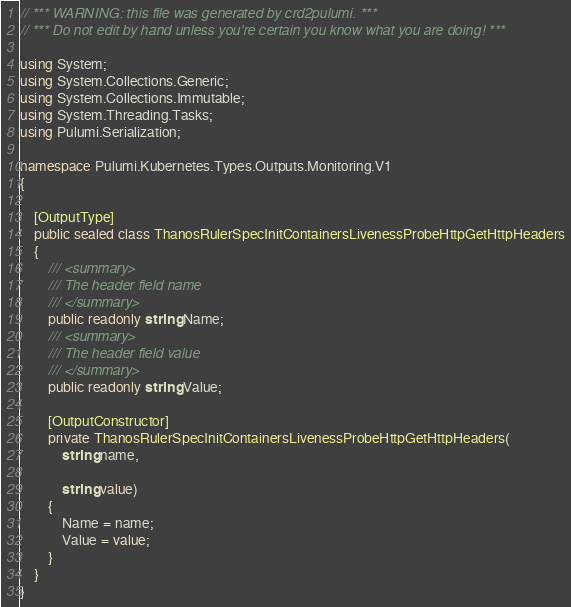Convert code to text. <code><loc_0><loc_0><loc_500><loc_500><_C#_>// *** WARNING: this file was generated by crd2pulumi. ***
// *** Do not edit by hand unless you're certain you know what you are doing! ***

using System;
using System.Collections.Generic;
using System.Collections.Immutable;
using System.Threading.Tasks;
using Pulumi.Serialization;

namespace Pulumi.Kubernetes.Types.Outputs.Monitoring.V1
{

    [OutputType]
    public sealed class ThanosRulerSpecInitContainersLivenessProbeHttpGetHttpHeaders
    {
        /// <summary>
        /// The header field name
        /// </summary>
        public readonly string Name;
        /// <summary>
        /// The header field value
        /// </summary>
        public readonly string Value;

        [OutputConstructor]
        private ThanosRulerSpecInitContainersLivenessProbeHttpGetHttpHeaders(
            string name,

            string value)
        {
            Name = name;
            Value = value;
        }
    }
}
</code> 